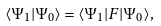Convert formula to latex. <formula><loc_0><loc_0><loc_500><loc_500>\langle \Psi _ { 1 } | \Psi _ { 0 } \rangle = \langle \Psi _ { 1 } | F | \Psi _ { 0 } \rangle ,</formula> 